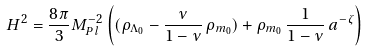Convert formula to latex. <formula><loc_0><loc_0><loc_500><loc_500>H ^ { 2 } = \frac { 8 \pi } { 3 } M _ { P l } ^ { - 2 } \left ( ( \rho _ { { \Lambda } _ { 0 } } - \frac { \nu } { 1 - \nu } \, \rho _ { { m } _ { 0 } } ) + \rho _ { { m } _ { 0 } } \, \frac { 1 } { 1 - \nu } \, a ^ { - \zeta } \right )</formula> 